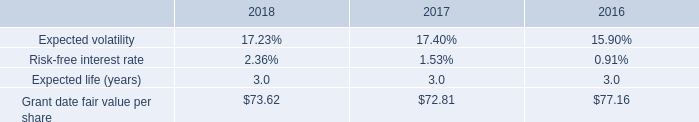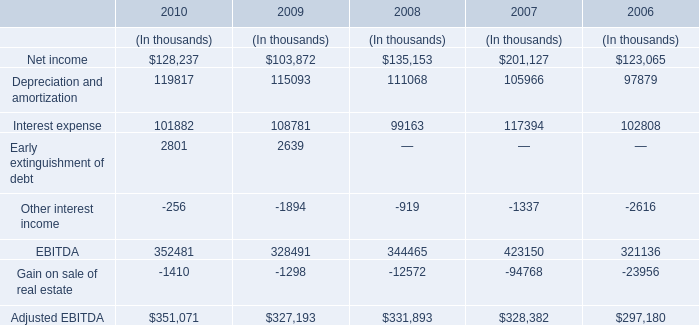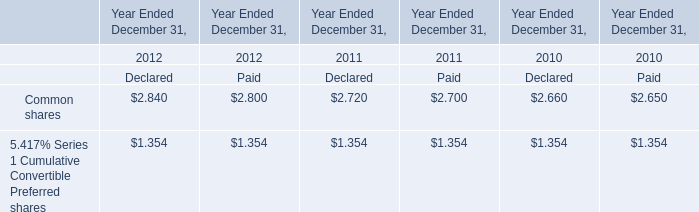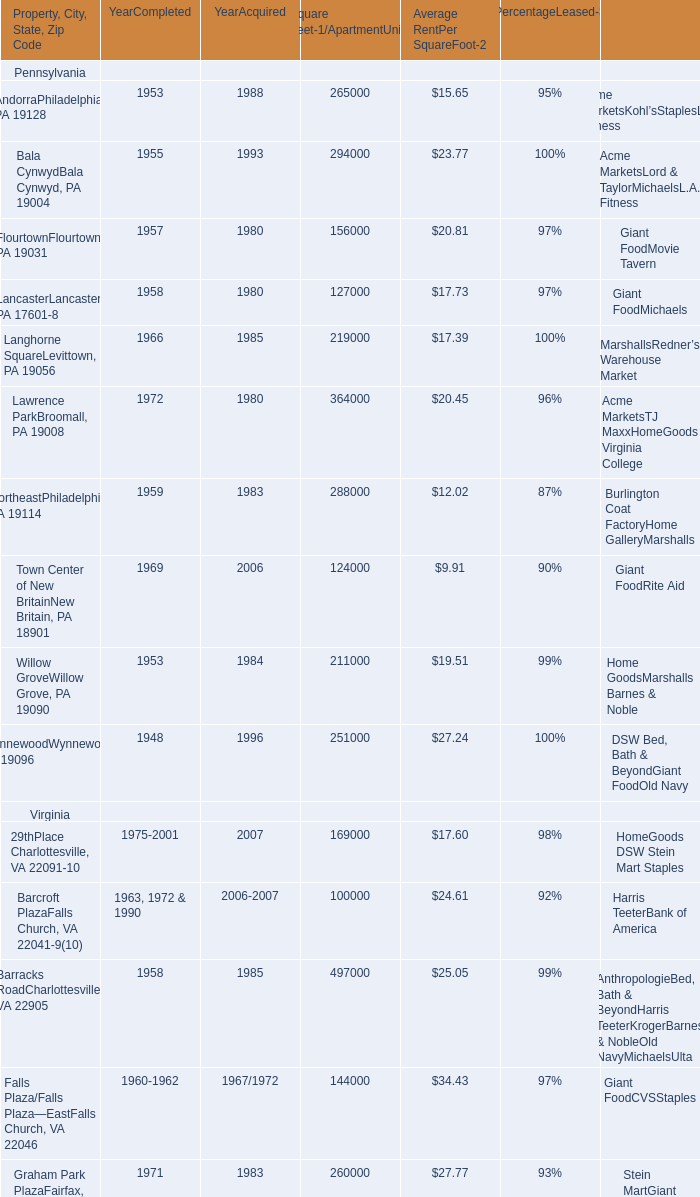What is the sum of AndorraPhiladelphia, PA 19128 Bala CynwydBala Cynwyd, PA 19004 and FlourtownFlourtown, PA 19031 for Average RentPer SquareFoot-2 ? 
Computations: ((15.65 + 23.77) + 20.81)
Answer: 60.23. 